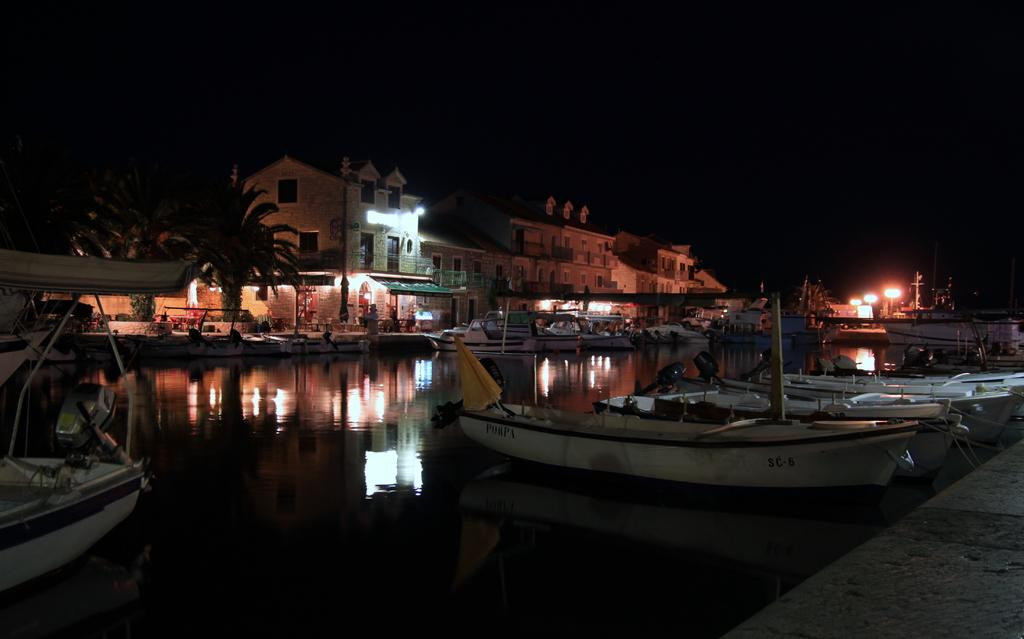What type of vehicles are on the water in the image? There are small white boats on the water in the image. What can be seen in the background of the image? There are white houses and coconut trees in the background. How would you describe the sky in the image? The sky is dark in the image. What type of dolls are being worn by the band members in the image? There are no dolls or band members present in the image. 